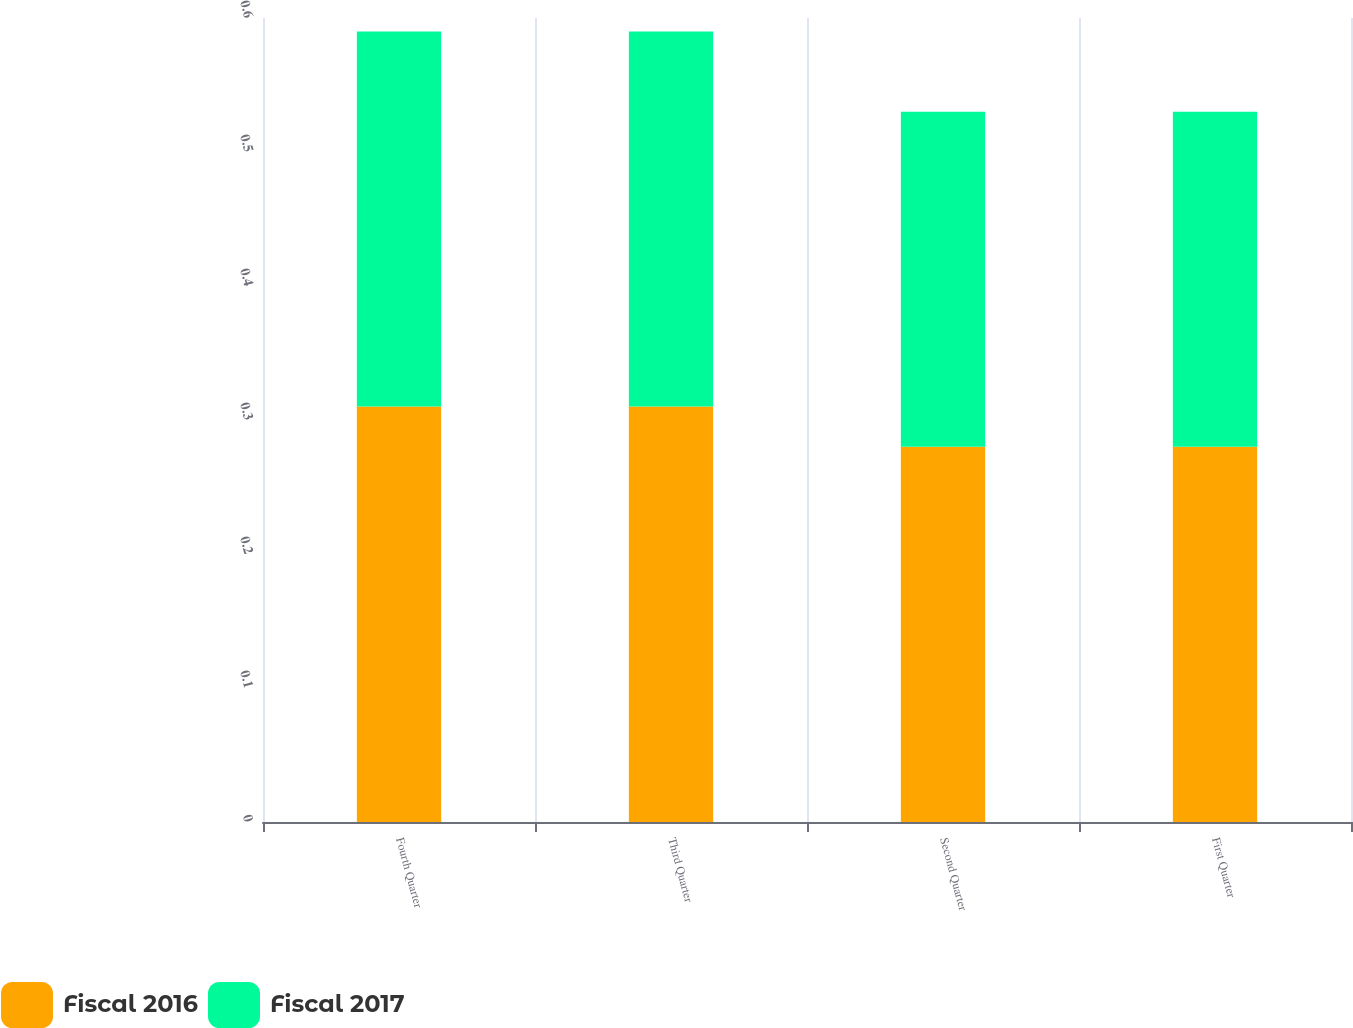<chart> <loc_0><loc_0><loc_500><loc_500><stacked_bar_chart><ecel><fcel>Fourth Quarter<fcel>Third Quarter<fcel>Second Quarter<fcel>First Quarter<nl><fcel>Fiscal 2016<fcel>0.31<fcel>0.31<fcel>0.28<fcel>0.28<nl><fcel>Fiscal 2017<fcel>0.28<fcel>0.28<fcel>0.25<fcel>0.25<nl></chart> 